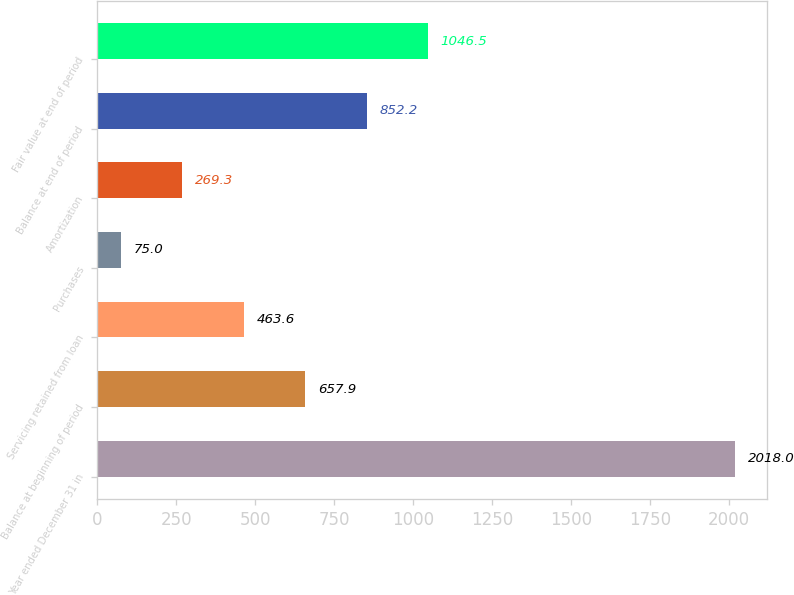Convert chart. <chart><loc_0><loc_0><loc_500><loc_500><bar_chart><fcel>Year ended December 31 in<fcel>Balance at beginning of period<fcel>Servicing retained from loan<fcel>Purchases<fcel>Amortization<fcel>Balance at end of period<fcel>Fair value at end of period<nl><fcel>2018<fcel>657.9<fcel>463.6<fcel>75<fcel>269.3<fcel>852.2<fcel>1046.5<nl></chart> 